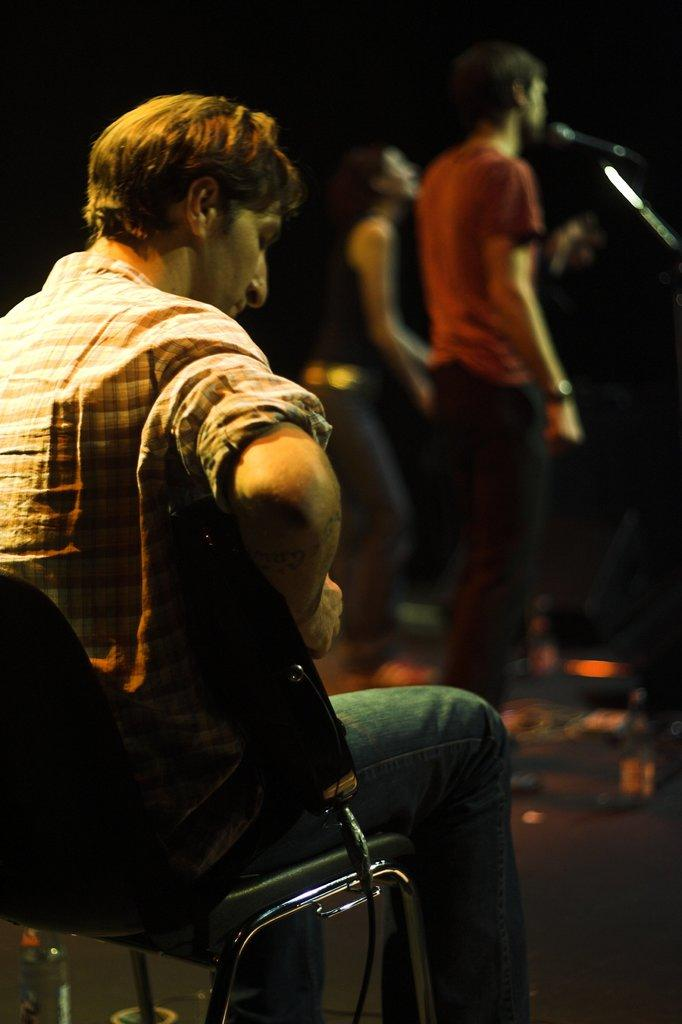Who is the main subject in the image? There is a man in the image. What is the man doing in the image? The man is sitting on a chair. Can you describe the background of the image? There are people standing in the background of the image. What color is the sun in the image? There is no sun present in the image. Can you describe the cart that the man is pushing in the image? There is no cart present in the image; the man is sitting on a chair. 